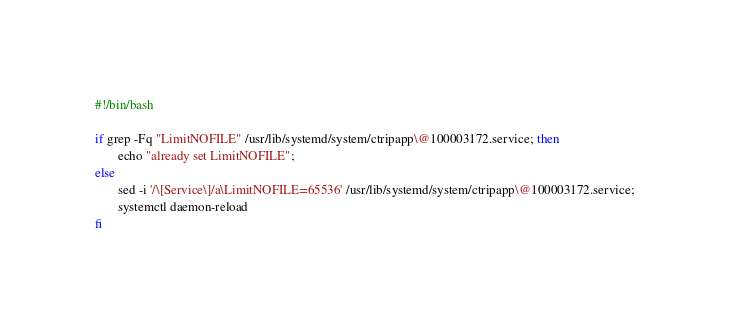Convert code to text. <code><loc_0><loc_0><loc_500><loc_500><_Bash_>#!/bin/bash

if grep -Fq "LimitNOFILE" /usr/lib/systemd/system/ctripapp\@100003172.service; then
       echo "already set LimitNOFILE";
else
       sed -i '/\[Service\]/a\LimitNOFILE=65536' /usr/lib/systemd/system/ctripapp\@100003172.service;
       systemctl daemon-reload
fi</code> 